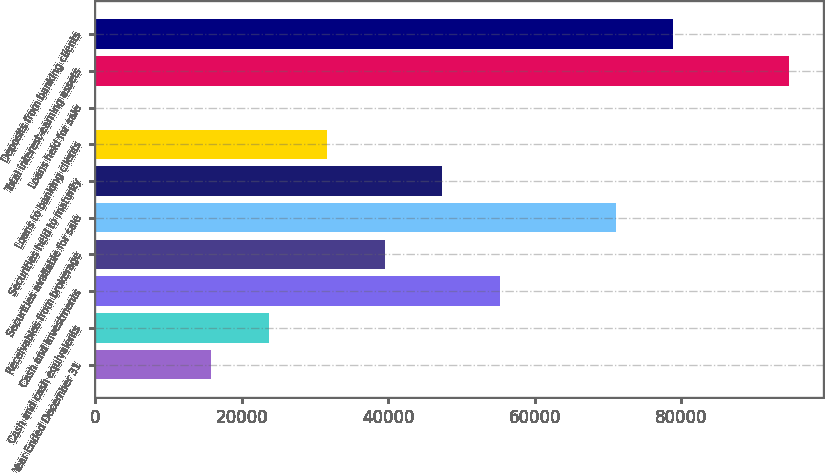Convert chart to OTSL. <chart><loc_0><loc_0><loc_500><loc_500><bar_chart><fcel>Year Ended December 31<fcel>Cash and cash equivalents<fcel>Cash and investments<fcel>Receivables from brokerage<fcel>Securities available for sale<fcel>Securities held to maturity<fcel>Loans to banking clients<fcel>Loans held for sale<fcel>Total interest-earning assets<fcel>Deposits from banking clients<nl><fcel>15844<fcel>23726<fcel>55254<fcel>39490<fcel>71018<fcel>47372<fcel>31608<fcel>80<fcel>94664<fcel>78900<nl></chart> 